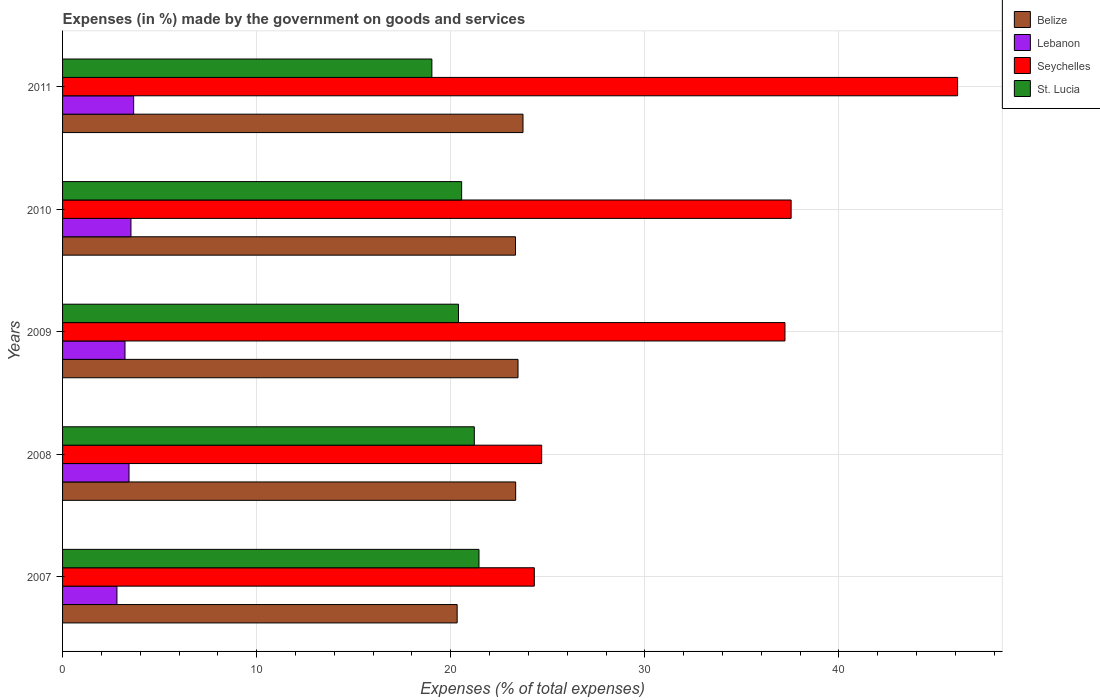How many different coloured bars are there?
Your answer should be very brief. 4. How many groups of bars are there?
Your response must be concise. 5. Are the number of bars per tick equal to the number of legend labels?
Give a very brief answer. Yes. How many bars are there on the 3rd tick from the top?
Give a very brief answer. 4. How many bars are there on the 4th tick from the bottom?
Keep it short and to the point. 4. In how many cases, is the number of bars for a given year not equal to the number of legend labels?
Your answer should be compact. 0. What is the percentage of expenses made by the government on goods and services in Lebanon in 2011?
Give a very brief answer. 3.66. Across all years, what is the maximum percentage of expenses made by the government on goods and services in Lebanon?
Offer a very short reply. 3.66. Across all years, what is the minimum percentage of expenses made by the government on goods and services in St. Lucia?
Your answer should be very brief. 19.03. In which year was the percentage of expenses made by the government on goods and services in Belize minimum?
Offer a very short reply. 2007. What is the total percentage of expenses made by the government on goods and services in Seychelles in the graph?
Keep it short and to the point. 169.87. What is the difference between the percentage of expenses made by the government on goods and services in Lebanon in 2008 and that in 2010?
Keep it short and to the point. -0.1. What is the difference between the percentage of expenses made by the government on goods and services in Seychelles in 2010 and the percentage of expenses made by the government on goods and services in Belize in 2008?
Provide a succinct answer. 14.19. What is the average percentage of expenses made by the government on goods and services in Lebanon per year?
Your response must be concise. 3.33. In the year 2008, what is the difference between the percentage of expenses made by the government on goods and services in Belize and percentage of expenses made by the government on goods and services in St. Lucia?
Provide a succinct answer. 2.13. In how many years, is the percentage of expenses made by the government on goods and services in St. Lucia greater than 22 %?
Give a very brief answer. 0. What is the ratio of the percentage of expenses made by the government on goods and services in Lebanon in 2007 to that in 2010?
Give a very brief answer. 0.8. Is the difference between the percentage of expenses made by the government on goods and services in Belize in 2010 and 2011 greater than the difference between the percentage of expenses made by the government on goods and services in St. Lucia in 2010 and 2011?
Provide a succinct answer. No. What is the difference between the highest and the second highest percentage of expenses made by the government on goods and services in Lebanon?
Your response must be concise. 0.14. What is the difference between the highest and the lowest percentage of expenses made by the government on goods and services in Lebanon?
Your answer should be compact. 0.86. What does the 1st bar from the top in 2007 represents?
Offer a very short reply. St. Lucia. What does the 2nd bar from the bottom in 2009 represents?
Offer a terse response. Lebanon. How many years are there in the graph?
Provide a short and direct response. 5. Does the graph contain any zero values?
Your response must be concise. No. Does the graph contain grids?
Your answer should be very brief. Yes. How are the legend labels stacked?
Make the answer very short. Vertical. What is the title of the graph?
Make the answer very short. Expenses (in %) made by the government on goods and services. What is the label or title of the X-axis?
Your answer should be compact. Expenses (% of total expenses). What is the label or title of the Y-axis?
Your response must be concise. Years. What is the Expenses (% of total expenses) of Belize in 2007?
Keep it short and to the point. 20.33. What is the Expenses (% of total expenses) of Lebanon in 2007?
Offer a very short reply. 2.8. What is the Expenses (% of total expenses) of Seychelles in 2007?
Give a very brief answer. 24.31. What is the Expenses (% of total expenses) in St. Lucia in 2007?
Ensure brevity in your answer.  21.46. What is the Expenses (% of total expenses) of Belize in 2008?
Make the answer very short. 23.35. What is the Expenses (% of total expenses) of Lebanon in 2008?
Ensure brevity in your answer.  3.42. What is the Expenses (% of total expenses) in Seychelles in 2008?
Keep it short and to the point. 24.69. What is the Expenses (% of total expenses) of St. Lucia in 2008?
Keep it short and to the point. 21.21. What is the Expenses (% of total expenses) in Belize in 2009?
Keep it short and to the point. 23.47. What is the Expenses (% of total expenses) of Lebanon in 2009?
Your answer should be compact. 3.22. What is the Expenses (% of total expenses) of Seychelles in 2009?
Offer a terse response. 37.22. What is the Expenses (% of total expenses) of St. Lucia in 2009?
Your response must be concise. 20.4. What is the Expenses (% of total expenses) of Belize in 2010?
Ensure brevity in your answer.  23.34. What is the Expenses (% of total expenses) in Lebanon in 2010?
Offer a terse response. 3.52. What is the Expenses (% of total expenses) in Seychelles in 2010?
Keep it short and to the point. 37.54. What is the Expenses (% of total expenses) in St. Lucia in 2010?
Give a very brief answer. 20.56. What is the Expenses (% of total expenses) of Belize in 2011?
Give a very brief answer. 23.72. What is the Expenses (% of total expenses) in Lebanon in 2011?
Keep it short and to the point. 3.66. What is the Expenses (% of total expenses) in Seychelles in 2011?
Your answer should be compact. 46.12. What is the Expenses (% of total expenses) of St. Lucia in 2011?
Provide a succinct answer. 19.03. Across all years, what is the maximum Expenses (% of total expenses) in Belize?
Ensure brevity in your answer.  23.72. Across all years, what is the maximum Expenses (% of total expenses) of Lebanon?
Offer a terse response. 3.66. Across all years, what is the maximum Expenses (% of total expenses) of Seychelles?
Provide a succinct answer. 46.12. Across all years, what is the maximum Expenses (% of total expenses) of St. Lucia?
Provide a short and direct response. 21.46. Across all years, what is the minimum Expenses (% of total expenses) of Belize?
Offer a very short reply. 20.33. Across all years, what is the minimum Expenses (% of total expenses) in Lebanon?
Your answer should be compact. 2.8. Across all years, what is the minimum Expenses (% of total expenses) in Seychelles?
Make the answer very short. 24.31. Across all years, what is the minimum Expenses (% of total expenses) of St. Lucia?
Provide a short and direct response. 19.03. What is the total Expenses (% of total expenses) of Belize in the graph?
Provide a succinct answer. 114.2. What is the total Expenses (% of total expenses) of Lebanon in the graph?
Give a very brief answer. 16.63. What is the total Expenses (% of total expenses) in Seychelles in the graph?
Your response must be concise. 169.87. What is the total Expenses (% of total expenses) in St. Lucia in the graph?
Keep it short and to the point. 102.66. What is the difference between the Expenses (% of total expenses) of Belize in 2007 and that in 2008?
Ensure brevity in your answer.  -3.01. What is the difference between the Expenses (% of total expenses) of Lebanon in 2007 and that in 2008?
Your answer should be very brief. -0.62. What is the difference between the Expenses (% of total expenses) of Seychelles in 2007 and that in 2008?
Provide a short and direct response. -0.38. What is the difference between the Expenses (% of total expenses) of St. Lucia in 2007 and that in 2008?
Provide a short and direct response. 0.24. What is the difference between the Expenses (% of total expenses) in Belize in 2007 and that in 2009?
Provide a short and direct response. -3.14. What is the difference between the Expenses (% of total expenses) in Lebanon in 2007 and that in 2009?
Your answer should be very brief. -0.42. What is the difference between the Expenses (% of total expenses) of Seychelles in 2007 and that in 2009?
Your answer should be compact. -12.91. What is the difference between the Expenses (% of total expenses) of St. Lucia in 2007 and that in 2009?
Ensure brevity in your answer.  1.06. What is the difference between the Expenses (% of total expenses) in Belize in 2007 and that in 2010?
Provide a short and direct response. -3.01. What is the difference between the Expenses (% of total expenses) in Lebanon in 2007 and that in 2010?
Make the answer very short. -0.72. What is the difference between the Expenses (% of total expenses) in Seychelles in 2007 and that in 2010?
Keep it short and to the point. -13.23. What is the difference between the Expenses (% of total expenses) of St. Lucia in 2007 and that in 2010?
Offer a very short reply. 0.89. What is the difference between the Expenses (% of total expenses) of Belize in 2007 and that in 2011?
Make the answer very short. -3.39. What is the difference between the Expenses (% of total expenses) of Lebanon in 2007 and that in 2011?
Offer a very short reply. -0.86. What is the difference between the Expenses (% of total expenses) in Seychelles in 2007 and that in 2011?
Provide a short and direct response. -21.81. What is the difference between the Expenses (% of total expenses) in St. Lucia in 2007 and that in 2011?
Offer a terse response. 2.43. What is the difference between the Expenses (% of total expenses) in Belize in 2008 and that in 2009?
Provide a short and direct response. -0.12. What is the difference between the Expenses (% of total expenses) in Lebanon in 2008 and that in 2009?
Provide a succinct answer. 0.21. What is the difference between the Expenses (% of total expenses) of Seychelles in 2008 and that in 2009?
Provide a succinct answer. -12.54. What is the difference between the Expenses (% of total expenses) of St. Lucia in 2008 and that in 2009?
Offer a very short reply. 0.82. What is the difference between the Expenses (% of total expenses) in Belize in 2008 and that in 2010?
Offer a terse response. 0.01. What is the difference between the Expenses (% of total expenses) of Lebanon in 2008 and that in 2010?
Give a very brief answer. -0.1. What is the difference between the Expenses (% of total expenses) in Seychelles in 2008 and that in 2010?
Offer a very short reply. -12.85. What is the difference between the Expenses (% of total expenses) of St. Lucia in 2008 and that in 2010?
Ensure brevity in your answer.  0.65. What is the difference between the Expenses (% of total expenses) in Belize in 2008 and that in 2011?
Ensure brevity in your answer.  -0.38. What is the difference between the Expenses (% of total expenses) of Lebanon in 2008 and that in 2011?
Your answer should be compact. -0.24. What is the difference between the Expenses (% of total expenses) in Seychelles in 2008 and that in 2011?
Offer a terse response. -21.43. What is the difference between the Expenses (% of total expenses) in St. Lucia in 2008 and that in 2011?
Offer a terse response. 2.19. What is the difference between the Expenses (% of total expenses) in Belize in 2009 and that in 2010?
Your response must be concise. 0.13. What is the difference between the Expenses (% of total expenses) of Lebanon in 2009 and that in 2010?
Provide a short and direct response. -0.31. What is the difference between the Expenses (% of total expenses) of Seychelles in 2009 and that in 2010?
Keep it short and to the point. -0.32. What is the difference between the Expenses (% of total expenses) of St. Lucia in 2009 and that in 2010?
Your answer should be compact. -0.16. What is the difference between the Expenses (% of total expenses) of Belize in 2009 and that in 2011?
Keep it short and to the point. -0.26. What is the difference between the Expenses (% of total expenses) of Lebanon in 2009 and that in 2011?
Keep it short and to the point. -0.45. What is the difference between the Expenses (% of total expenses) of Seychelles in 2009 and that in 2011?
Ensure brevity in your answer.  -8.89. What is the difference between the Expenses (% of total expenses) in St. Lucia in 2009 and that in 2011?
Your answer should be compact. 1.37. What is the difference between the Expenses (% of total expenses) in Belize in 2010 and that in 2011?
Your answer should be compact. -0.39. What is the difference between the Expenses (% of total expenses) in Lebanon in 2010 and that in 2011?
Your answer should be very brief. -0.14. What is the difference between the Expenses (% of total expenses) in Seychelles in 2010 and that in 2011?
Provide a succinct answer. -8.58. What is the difference between the Expenses (% of total expenses) of St. Lucia in 2010 and that in 2011?
Give a very brief answer. 1.53. What is the difference between the Expenses (% of total expenses) of Belize in 2007 and the Expenses (% of total expenses) of Lebanon in 2008?
Give a very brief answer. 16.91. What is the difference between the Expenses (% of total expenses) of Belize in 2007 and the Expenses (% of total expenses) of Seychelles in 2008?
Make the answer very short. -4.35. What is the difference between the Expenses (% of total expenses) of Belize in 2007 and the Expenses (% of total expenses) of St. Lucia in 2008?
Your answer should be compact. -0.88. What is the difference between the Expenses (% of total expenses) of Lebanon in 2007 and the Expenses (% of total expenses) of Seychelles in 2008?
Give a very brief answer. -21.88. What is the difference between the Expenses (% of total expenses) of Lebanon in 2007 and the Expenses (% of total expenses) of St. Lucia in 2008?
Provide a short and direct response. -18.41. What is the difference between the Expenses (% of total expenses) in Seychelles in 2007 and the Expenses (% of total expenses) in St. Lucia in 2008?
Provide a succinct answer. 3.09. What is the difference between the Expenses (% of total expenses) of Belize in 2007 and the Expenses (% of total expenses) of Lebanon in 2009?
Offer a very short reply. 17.11. What is the difference between the Expenses (% of total expenses) of Belize in 2007 and the Expenses (% of total expenses) of Seychelles in 2009?
Keep it short and to the point. -16.89. What is the difference between the Expenses (% of total expenses) in Belize in 2007 and the Expenses (% of total expenses) in St. Lucia in 2009?
Give a very brief answer. -0.07. What is the difference between the Expenses (% of total expenses) of Lebanon in 2007 and the Expenses (% of total expenses) of Seychelles in 2009?
Provide a succinct answer. -34.42. What is the difference between the Expenses (% of total expenses) in Lebanon in 2007 and the Expenses (% of total expenses) in St. Lucia in 2009?
Keep it short and to the point. -17.6. What is the difference between the Expenses (% of total expenses) of Seychelles in 2007 and the Expenses (% of total expenses) of St. Lucia in 2009?
Provide a succinct answer. 3.91. What is the difference between the Expenses (% of total expenses) in Belize in 2007 and the Expenses (% of total expenses) in Lebanon in 2010?
Make the answer very short. 16.81. What is the difference between the Expenses (% of total expenses) of Belize in 2007 and the Expenses (% of total expenses) of Seychelles in 2010?
Provide a short and direct response. -17.21. What is the difference between the Expenses (% of total expenses) of Belize in 2007 and the Expenses (% of total expenses) of St. Lucia in 2010?
Offer a terse response. -0.23. What is the difference between the Expenses (% of total expenses) of Lebanon in 2007 and the Expenses (% of total expenses) of Seychelles in 2010?
Offer a terse response. -34.74. What is the difference between the Expenses (% of total expenses) of Lebanon in 2007 and the Expenses (% of total expenses) of St. Lucia in 2010?
Your answer should be compact. -17.76. What is the difference between the Expenses (% of total expenses) in Seychelles in 2007 and the Expenses (% of total expenses) in St. Lucia in 2010?
Provide a succinct answer. 3.74. What is the difference between the Expenses (% of total expenses) in Belize in 2007 and the Expenses (% of total expenses) in Lebanon in 2011?
Provide a succinct answer. 16.67. What is the difference between the Expenses (% of total expenses) of Belize in 2007 and the Expenses (% of total expenses) of Seychelles in 2011?
Keep it short and to the point. -25.78. What is the difference between the Expenses (% of total expenses) of Belize in 2007 and the Expenses (% of total expenses) of St. Lucia in 2011?
Provide a succinct answer. 1.3. What is the difference between the Expenses (% of total expenses) of Lebanon in 2007 and the Expenses (% of total expenses) of Seychelles in 2011?
Your answer should be very brief. -43.31. What is the difference between the Expenses (% of total expenses) of Lebanon in 2007 and the Expenses (% of total expenses) of St. Lucia in 2011?
Offer a terse response. -16.23. What is the difference between the Expenses (% of total expenses) in Seychelles in 2007 and the Expenses (% of total expenses) in St. Lucia in 2011?
Your answer should be very brief. 5.28. What is the difference between the Expenses (% of total expenses) of Belize in 2008 and the Expenses (% of total expenses) of Lebanon in 2009?
Give a very brief answer. 20.13. What is the difference between the Expenses (% of total expenses) of Belize in 2008 and the Expenses (% of total expenses) of Seychelles in 2009?
Provide a succinct answer. -13.88. What is the difference between the Expenses (% of total expenses) of Belize in 2008 and the Expenses (% of total expenses) of St. Lucia in 2009?
Keep it short and to the point. 2.95. What is the difference between the Expenses (% of total expenses) in Lebanon in 2008 and the Expenses (% of total expenses) in Seychelles in 2009?
Offer a very short reply. -33.8. What is the difference between the Expenses (% of total expenses) of Lebanon in 2008 and the Expenses (% of total expenses) of St. Lucia in 2009?
Make the answer very short. -16.98. What is the difference between the Expenses (% of total expenses) in Seychelles in 2008 and the Expenses (% of total expenses) in St. Lucia in 2009?
Your response must be concise. 4.29. What is the difference between the Expenses (% of total expenses) of Belize in 2008 and the Expenses (% of total expenses) of Lebanon in 2010?
Keep it short and to the point. 19.82. What is the difference between the Expenses (% of total expenses) in Belize in 2008 and the Expenses (% of total expenses) in Seychelles in 2010?
Provide a succinct answer. -14.19. What is the difference between the Expenses (% of total expenses) in Belize in 2008 and the Expenses (% of total expenses) in St. Lucia in 2010?
Your answer should be compact. 2.78. What is the difference between the Expenses (% of total expenses) of Lebanon in 2008 and the Expenses (% of total expenses) of Seychelles in 2010?
Ensure brevity in your answer.  -34.11. What is the difference between the Expenses (% of total expenses) of Lebanon in 2008 and the Expenses (% of total expenses) of St. Lucia in 2010?
Provide a short and direct response. -17.14. What is the difference between the Expenses (% of total expenses) in Seychelles in 2008 and the Expenses (% of total expenses) in St. Lucia in 2010?
Make the answer very short. 4.12. What is the difference between the Expenses (% of total expenses) in Belize in 2008 and the Expenses (% of total expenses) in Lebanon in 2011?
Your answer should be compact. 19.68. What is the difference between the Expenses (% of total expenses) of Belize in 2008 and the Expenses (% of total expenses) of Seychelles in 2011?
Give a very brief answer. -22.77. What is the difference between the Expenses (% of total expenses) of Belize in 2008 and the Expenses (% of total expenses) of St. Lucia in 2011?
Your response must be concise. 4.32. What is the difference between the Expenses (% of total expenses) in Lebanon in 2008 and the Expenses (% of total expenses) in Seychelles in 2011?
Offer a very short reply. -42.69. What is the difference between the Expenses (% of total expenses) in Lebanon in 2008 and the Expenses (% of total expenses) in St. Lucia in 2011?
Give a very brief answer. -15.61. What is the difference between the Expenses (% of total expenses) in Seychelles in 2008 and the Expenses (% of total expenses) in St. Lucia in 2011?
Provide a succinct answer. 5.66. What is the difference between the Expenses (% of total expenses) of Belize in 2009 and the Expenses (% of total expenses) of Lebanon in 2010?
Provide a short and direct response. 19.94. What is the difference between the Expenses (% of total expenses) in Belize in 2009 and the Expenses (% of total expenses) in Seychelles in 2010?
Your answer should be very brief. -14.07. What is the difference between the Expenses (% of total expenses) of Belize in 2009 and the Expenses (% of total expenses) of St. Lucia in 2010?
Offer a terse response. 2.91. What is the difference between the Expenses (% of total expenses) of Lebanon in 2009 and the Expenses (% of total expenses) of Seychelles in 2010?
Your answer should be compact. -34.32. What is the difference between the Expenses (% of total expenses) of Lebanon in 2009 and the Expenses (% of total expenses) of St. Lucia in 2010?
Your answer should be compact. -17.34. What is the difference between the Expenses (% of total expenses) in Seychelles in 2009 and the Expenses (% of total expenses) in St. Lucia in 2010?
Provide a succinct answer. 16.66. What is the difference between the Expenses (% of total expenses) in Belize in 2009 and the Expenses (% of total expenses) in Lebanon in 2011?
Your answer should be compact. 19.8. What is the difference between the Expenses (% of total expenses) of Belize in 2009 and the Expenses (% of total expenses) of Seychelles in 2011?
Give a very brief answer. -22.65. What is the difference between the Expenses (% of total expenses) of Belize in 2009 and the Expenses (% of total expenses) of St. Lucia in 2011?
Keep it short and to the point. 4.44. What is the difference between the Expenses (% of total expenses) in Lebanon in 2009 and the Expenses (% of total expenses) in Seychelles in 2011?
Offer a very short reply. -42.9. What is the difference between the Expenses (% of total expenses) of Lebanon in 2009 and the Expenses (% of total expenses) of St. Lucia in 2011?
Ensure brevity in your answer.  -15.81. What is the difference between the Expenses (% of total expenses) in Seychelles in 2009 and the Expenses (% of total expenses) in St. Lucia in 2011?
Provide a succinct answer. 18.19. What is the difference between the Expenses (% of total expenses) in Belize in 2010 and the Expenses (% of total expenses) in Lebanon in 2011?
Your answer should be very brief. 19.67. What is the difference between the Expenses (% of total expenses) of Belize in 2010 and the Expenses (% of total expenses) of Seychelles in 2011?
Ensure brevity in your answer.  -22.78. What is the difference between the Expenses (% of total expenses) of Belize in 2010 and the Expenses (% of total expenses) of St. Lucia in 2011?
Your answer should be compact. 4.31. What is the difference between the Expenses (% of total expenses) of Lebanon in 2010 and the Expenses (% of total expenses) of Seychelles in 2011?
Your answer should be compact. -42.59. What is the difference between the Expenses (% of total expenses) in Lebanon in 2010 and the Expenses (% of total expenses) in St. Lucia in 2011?
Keep it short and to the point. -15.51. What is the difference between the Expenses (% of total expenses) of Seychelles in 2010 and the Expenses (% of total expenses) of St. Lucia in 2011?
Ensure brevity in your answer.  18.51. What is the average Expenses (% of total expenses) in Belize per year?
Make the answer very short. 22.84. What is the average Expenses (% of total expenses) in Lebanon per year?
Give a very brief answer. 3.33. What is the average Expenses (% of total expenses) in Seychelles per year?
Give a very brief answer. 33.97. What is the average Expenses (% of total expenses) in St. Lucia per year?
Your answer should be very brief. 20.53. In the year 2007, what is the difference between the Expenses (% of total expenses) of Belize and Expenses (% of total expenses) of Lebanon?
Provide a succinct answer. 17.53. In the year 2007, what is the difference between the Expenses (% of total expenses) of Belize and Expenses (% of total expenses) of Seychelles?
Your answer should be compact. -3.98. In the year 2007, what is the difference between the Expenses (% of total expenses) of Belize and Expenses (% of total expenses) of St. Lucia?
Provide a succinct answer. -1.12. In the year 2007, what is the difference between the Expenses (% of total expenses) in Lebanon and Expenses (% of total expenses) in Seychelles?
Your response must be concise. -21.5. In the year 2007, what is the difference between the Expenses (% of total expenses) in Lebanon and Expenses (% of total expenses) in St. Lucia?
Provide a succinct answer. -18.65. In the year 2007, what is the difference between the Expenses (% of total expenses) in Seychelles and Expenses (% of total expenses) in St. Lucia?
Your answer should be compact. 2.85. In the year 2008, what is the difference between the Expenses (% of total expenses) of Belize and Expenses (% of total expenses) of Lebanon?
Your answer should be very brief. 19.92. In the year 2008, what is the difference between the Expenses (% of total expenses) in Belize and Expenses (% of total expenses) in Seychelles?
Your answer should be very brief. -1.34. In the year 2008, what is the difference between the Expenses (% of total expenses) in Belize and Expenses (% of total expenses) in St. Lucia?
Make the answer very short. 2.13. In the year 2008, what is the difference between the Expenses (% of total expenses) in Lebanon and Expenses (% of total expenses) in Seychelles?
Your answer should be very brief. -21.26. In the year 2008, what is the difference between the Expenses (% of total expenses) in Lebanon and Expenses (% of total expenses) in St. Lucia?
Give a very brief answer. -17.79. In the year 2008, what is the difference between the Expenses (% of total expenses) of Seychelles and Expenses (% of total expenses) of St. Lucia?
Make the answer very short. 3.47. In the year 2009, what is the difference between the Expenses (% of total expenses) of Belize and Expenses (% of total expenses) of Lebanon?
Make the answer very short. 20.25. In the year 2009, what is the difference between the Expenses (% of total expenses) of Belize and Expenses (% of total expenses) of Seychelles?
Make the answer very short. -13.75. In the year 2009, what is the difference between the Expenses (% of total expenses) in Belize and Expenses (% of total expenses) in St. Lucia?
Provide a succinct answer. 3.07. In the year 2009, what is the difference between the Expenses (% of total expenses) of Lebanon and Expenses (% of total expenses) of Seychelles?
Make the answer very short. -34. In the year 2009, what is the difference between the Expenses (% of total expenses) of Lebanon and Expenses (% of total expenses) of St. Lucia?
Offer a very short reply. -17.18. In the year 2009, what is the difference between the Expenses (% of total expenses) in Seychelles and Expenses (% of total expenses) in St. Lucia?
Provide a succinct answer. 16.82. In the year 2010, what is the difference between the Expenses (% of total expenses) of Belize and Expenses (% of total expenses) of Lebanon?
Ensure brevity in your answer.  19.81. In the year 2010, what is the difference between the Expenses (% of total expenses) in Belize and Expenses (% of total expenses) in Seychelles?
Provide a short and direct response. -14.2. In the year 2010, what is the difference between the Expenses (% of total expenses) in Belize and Expenses (% of total expenses) in St. Lucia?
Ensure brevity in your answer.  2.78. In the year 2010, what is the difference between the Expenses (% of total expenses) of Lebanon and Expenses (% of total expenses) of Seychelles?
Make the answer very short. -34.02. In the year 2010, what is the difference between the Expenses (% of total expenses) of Lebanon and Expenses (% of total expenses) of St. Lucia?
Provide a short and direct response. -17.04. In the year 2010, what is the difference between the Expenses (% of total expenses) of Seychelles and Expenses (% of total expenses) of St. Lucia?
Make the answer very short. 16.98. In the year 2011, what is the difference between the Expenses (% of total expenses) in Belize and Expenses (% of total expenses) in Lebanon?
Provide a short and direct response. 20.06. In the year 2011, what is the difference between the Expenses (% of total expenses) of Belize and Expenses (% of total expenses) of Seychelles?
Your answer should be compact. -22.39. In the year 2011, what is the difference between the Expenses (% of total expenses) in Belize and Expenses (% of total expenses) in St. Lucia?
Provide a short and direct response. 4.69. In the year 2011, what is the difference between the Expenses (% of total expenses) of Lebanon and Expenses (% of total expenses) of Seychelles?
Keep it short and to the point. -42.45. In the year 2011, what is the difference between the Expenses (% of total expenses) of Lebanon and Expenses (% of total expenses) of St. Lucia?
Your answer should be compact. -15.37. In the year 2011, what is the difference between the Expenses (% of total expenses) of Seychelles and Expenses (% of total expenses) of St. Lucia?
Your answer should be compact. 27.09. What is the ratio of the Expenses (% of total expenses) in Belize in 2007 to that in 2008?
Offer a very short reply. 0.87. What is the ratio of the Expenses (% of total expenses) in Lebanon in 2007 to that in 2008?
Provide a succinct answer. 0.82. What is the ratio of the Expenses (% of total expenses) of Seychelles in 2007 to that in 2008?
Offer a terse response. 0.98. What is the ratio of the Expenses (% of total expenses) in St. Lucia in 2007 to that in 2008?
Make the answer very short. 1.01. What is the ratio of the Expenses (% of total expenses) in Belize in 2007 to that in 2009?
Keep it short and to the point. 0.87. What is the ratio of the Expenses (% of total expenses) in Lebanon in 2007 to that in 2009?
Provide a succinct answer. 0.87. What is the ratio of the Expenses (% of total expenses) in Seychelles in 2007 to that in 2009?
Your answer should be very brief. 0.65. What is the ratio of the Expenses (% of total expenses) in St. Lucia in 2007 to that in 2009?
Ensure brevity in your answer.  1.05. What is the ratio of the Expenses (% of total expenses) of Belize in 2007 to that in 2010?
Give a very brief answer. 0.87. What is the ratio of the Expenses (% of total expenses) in Lebanon in 2007 to that in 2010?
Your answer should be compact. 0.8. What is the ratio of the Expenses (% of total expenses) in Seychelles in 2007 to that in 2010?
Give a very brief answer. 0.65. What is the ratio of the Expenses (% of total expenses) of St. Lucia in 2007 to that in 2010?
Give a very brief answer. 1.04. What is the ratio of the Expenses (% of total expenses) of Belize in 2007 to that in 2011?
Offer a very short reply. 0.86. What is the ratio of the Expenses (% of total expenses) of Lebanon in 2007 to that in 2011?
Give a very brief answer. 0.76. What is the ratio of the Expenses (% of total expenses) in Seychelles in 2007 to that in 2011?
Your answer should be compact. 0.53. What is the ratio of the Expenses (% of total expenses) in St. Lucia in 2007 to that in 2011?
Your answer should be compact. 1.13. What is the ratio of the Expenses (% of total expenses) of Lebanon in 2008 to that in 2009?
Your answer should be very brief. 1.06. What is the ratio of the Expenses (% of total expenses) of Seychelles in 2008 to that in 2009?
Your answer should be compact. 0.66. What is the ratio of the Expenses (% of total expenses) in St. Lucia in 2008 to that in 2009?
Provide a short and direct response. 1.04. What is the ratio of the Expenses (% of total expenses) of Belize in 2008 to that in 2010?
Offer a very short reply. 1. What is the ratio of the Expenses (% of total expenses) in Lebanon in 2008 to that in 2010?
Your answer should be compact. 0.97. What is the ratio of the Expenses (% of total expenses) in Seychelles in 2008 to that in 2010?
Provide a succinct answer. 0.66. What is the ratio of the Expenses (% of total expenses) of St. Lucia in 2008 to that in 2010?
Make the answer very short. 1.03. What is the ratio of the Expenses (% of total expenses) of Belize in 2008 to that in 2011?
Your answer should be compact. 0.98. What is the ratio of the Expenses (% of total expenses) in Lebanon in 2008 to that in 2011?
Your answer should be very brief. 0.93. What is the ratio of the Expenses (% of total expenses) of Seychelles in 2008 to that in 2011?
Your answer should be compact. 0.54. What is the ratio of the Expenses (% of total expenses) of St. Lucia in 2008 to that in 2011?
Make the answer very short. 1.11. What is the ratio of the Expenses (% of total expenses) in Belize in 2009 to that in 2010?
Ensure brevity in your answer.  1.01. What is the ratio of the Expenses (% of total expenses) of Lebanon in 2009 to that in 2010?
Offer a terse response. 0.91. What is the ratio of the Expenses (% of total expenses) of St. Lucia in 2009 to that in 2010?
Make the answer very short. 0.99. What is the ratio of the Expenses (% of total expenses) of Belize in 2009 to that in 2011?
Give a very brief answer. 0.99. What is the ratio of the Expenses (% of total expenses) of Lebanon in 2009 to that in 2011?
Give a very brief answer. 0.88. What is the ratio of the Expenses (% of total expenses) of Seychelles in 2009 to that in 2011?
Your answer should be very brief. 0.81. What is the ratio of the Expenses (% of total expenses) in St. Lucia in 2009 to that in 2011?
Offer a terse response. 1.07. What is the ratio of the Expenses (% of total expenses) in Belize in 2010 to that in 2011?
Your answer should be compact. 0.98. What is the ratio of the Expenses (% of total expenses) of Lebanon in 2010 to that in 2011?
Offer a terse response. 0.96. What is the ratio of the Expenses (% of total expenses) in Seychelles in 2010 to that in 2011?
Your response must be concise. 0.81. What is the ratio of the Expenses (% of total expenses) of St. Lucia in 2010 to that in 2011?
Give a very brief answer. 1.08. What is the difference between the highest and the second highest Expenses (% of total expenses) of Belize?
Give a very brief answer. 0.26. What is the difference between the highest and the second highest Expenses (% of total expenses) in Lebanon?
Keep it short and to the point. 0.14. What is the difference between the highest and the second highest Expenses (% of total expenses) in Seychelles?
Provide a short and direct response. 8.58. What is the difference between the highest and the second highest Expenses (% of total expenses) in St. Lucia?
Keep it short and to the point. 0.24. What is the difference between the highest and the lowest Expenses (% of total expenses) of Belize?
Provide a succinct answer. 3.39. What is the difference between the highest and the lowest Expenses (% of total expenses) in Lebanon?
Your response must be concise. 0.86. What is the difference between the highest and the lowest Expenses (% of total expenses) of Seychelles?
Give a very brief answer. 21.81. What is the difference between the highest and the lowest Expenses (% of total expenses) of St. Lucia?
Provide a succinct answer. 2.43. 